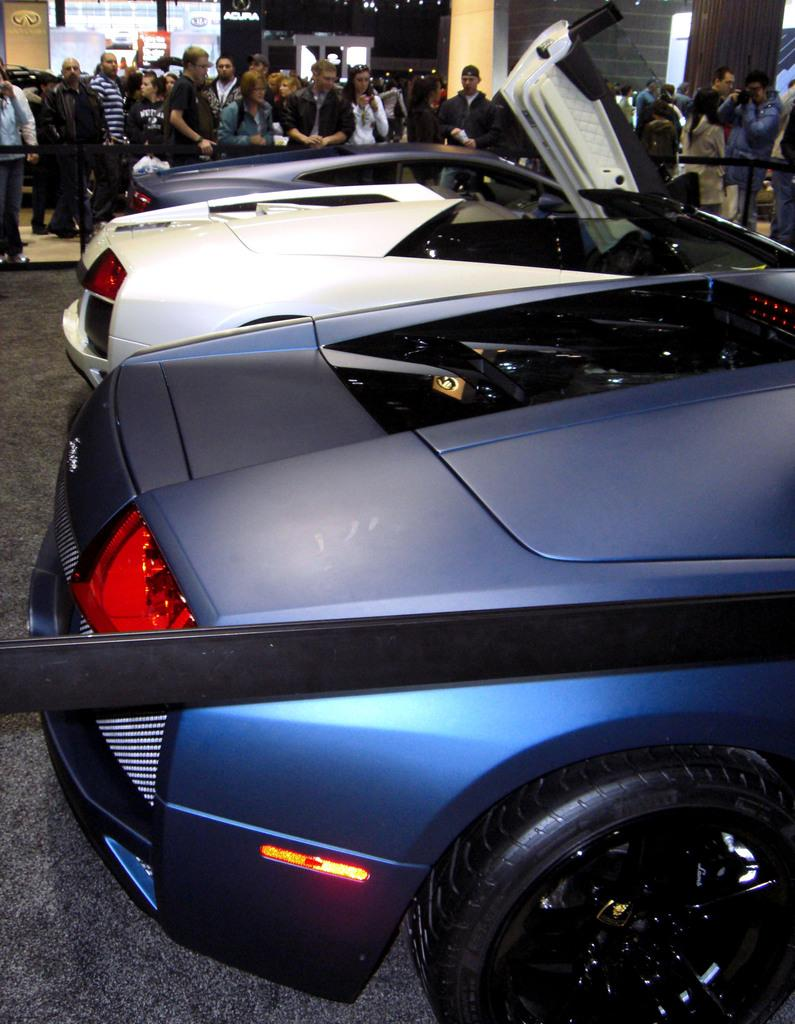What is the main subject of the image? The main subject of the image is many cars parked in one place. Is there anything unusual about the way the cars are parked? Yes, there is a belt around the parked cars. Are there any people present in the image? Yes, some people are standing near the cars. What are the people doing in the image? The people are watching the cars. What type of design can be seen on the bells in the image? There are no bells present in the image; it features parked cars with a belt around them and people watching. 